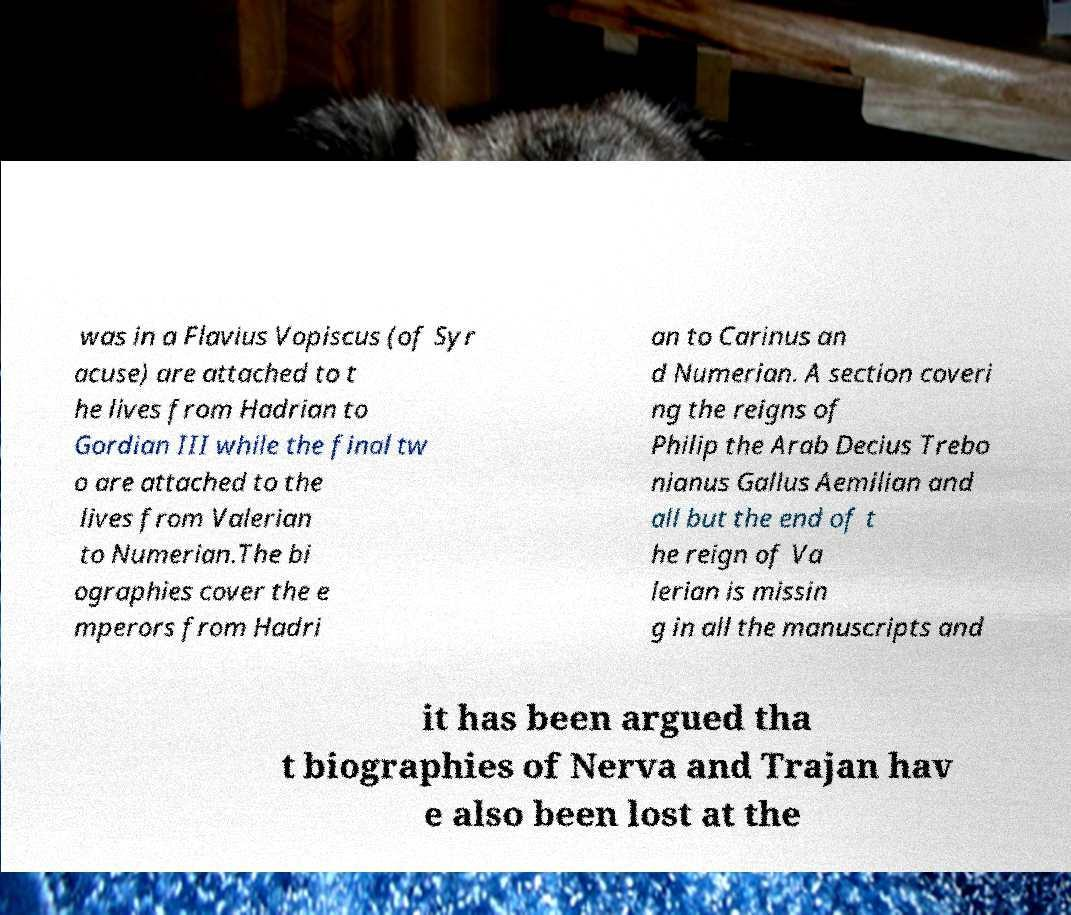Could you extract and type out the text from this image? was in a Flavius Vopiscus (of Syr acuse) are attached to t he lives from Hadrian to Gordian III while the final tw o are attached to the lives from Valerian to Numerian.The bi ographies cover the e mperors from Hadri an to Carinus an d Numerian. A section coveri ng the reigns of Philip the Arab Decius Trebo nianus Gallus Aemilian and all but the end of t he reign of Va lerian is missin g in all the manuscripts and it has been argued tha t biographies of Nerva and Trajan hav e also been lost at the 